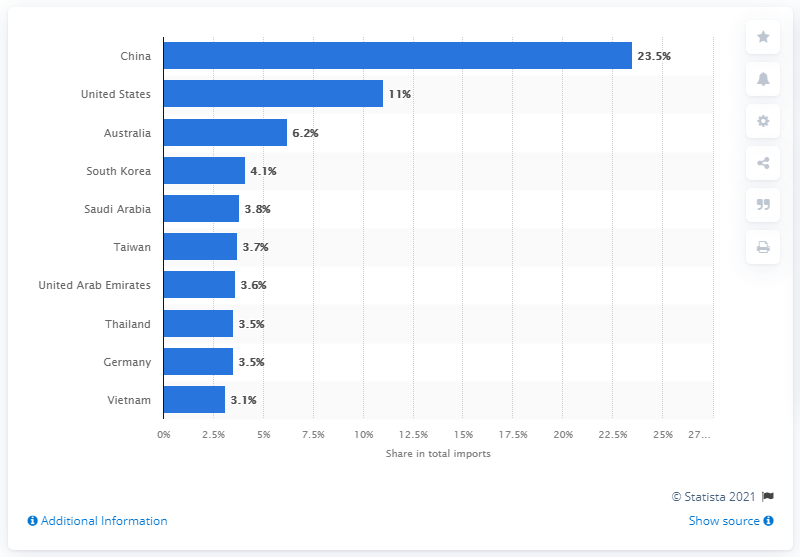Mention a couple of crucial points in this snapshot. In 2019, Japan's main import partner was China. 